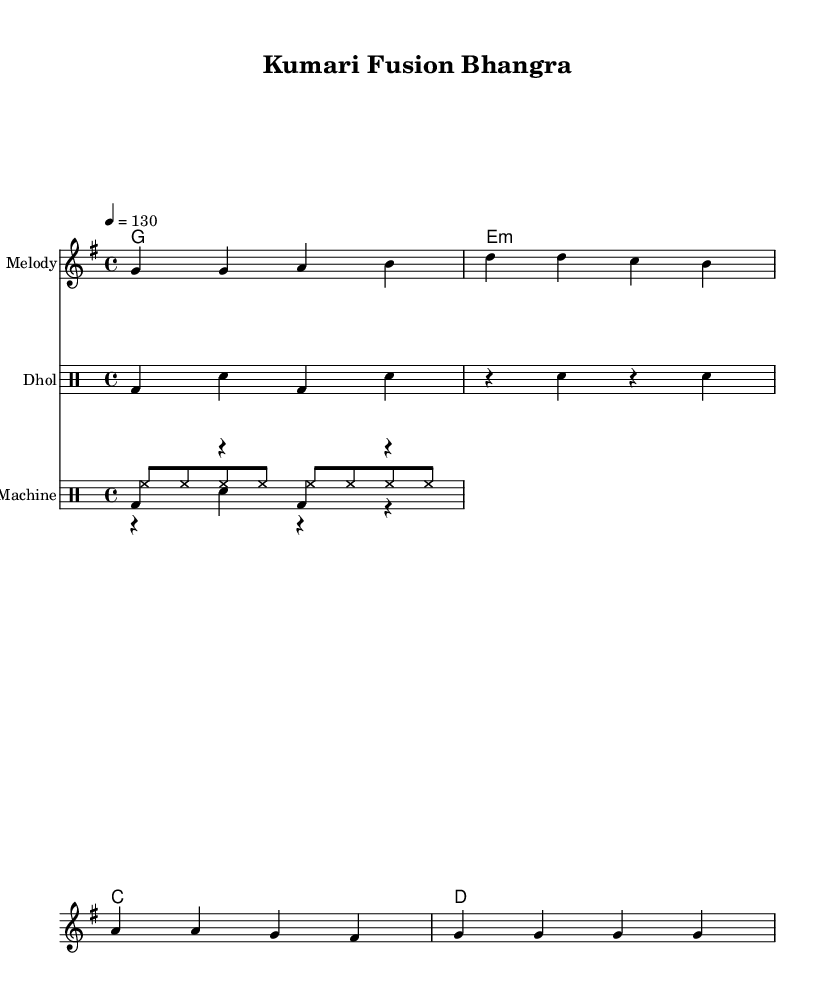What is the key signature of this music? The key signature indicated in the global section is G major, which has one sharp. This can be identified by looking for the "g \major" command.
Answer: G major What is the time signature of this music? The time signature is indicated as 4/4 in the global section of the code. This is specified by the "time 4/4" command.
Answer: 4/4 What is the tempo marking of this piece? The tempo marking is specified as "4 = 130". This means that there are 130 beats per minute, which can be seen under the global section.
Answer: 130 How many measures are in the melody section? The melody section includes four measures, as evidenced by the four groups of notes separated by vertical bars.
Answer: 4 What percussion instruments are used in this music? The music features "Dhol" and "Drum Machine" as percussion instruments, which are listed under the respective staff sections.
Answer: Dhol and Drum Machine Which chord is played in the first measure? The first chord indicated in the chordNames section is G, represented by "g1." This can be found at the beginning of the chord progression.
Answer: G What rhythmic pattern do the snare and kick play together? The kick pattern consists of two bass drum notes alternating with two rests, while the snare plays a consistent pattern. Together, they create a layered rhythm essential for dance music. This can be understood by analyzing both the kickPattern and snarePattern sections.
Answer: Combined kick and snare rhythm 